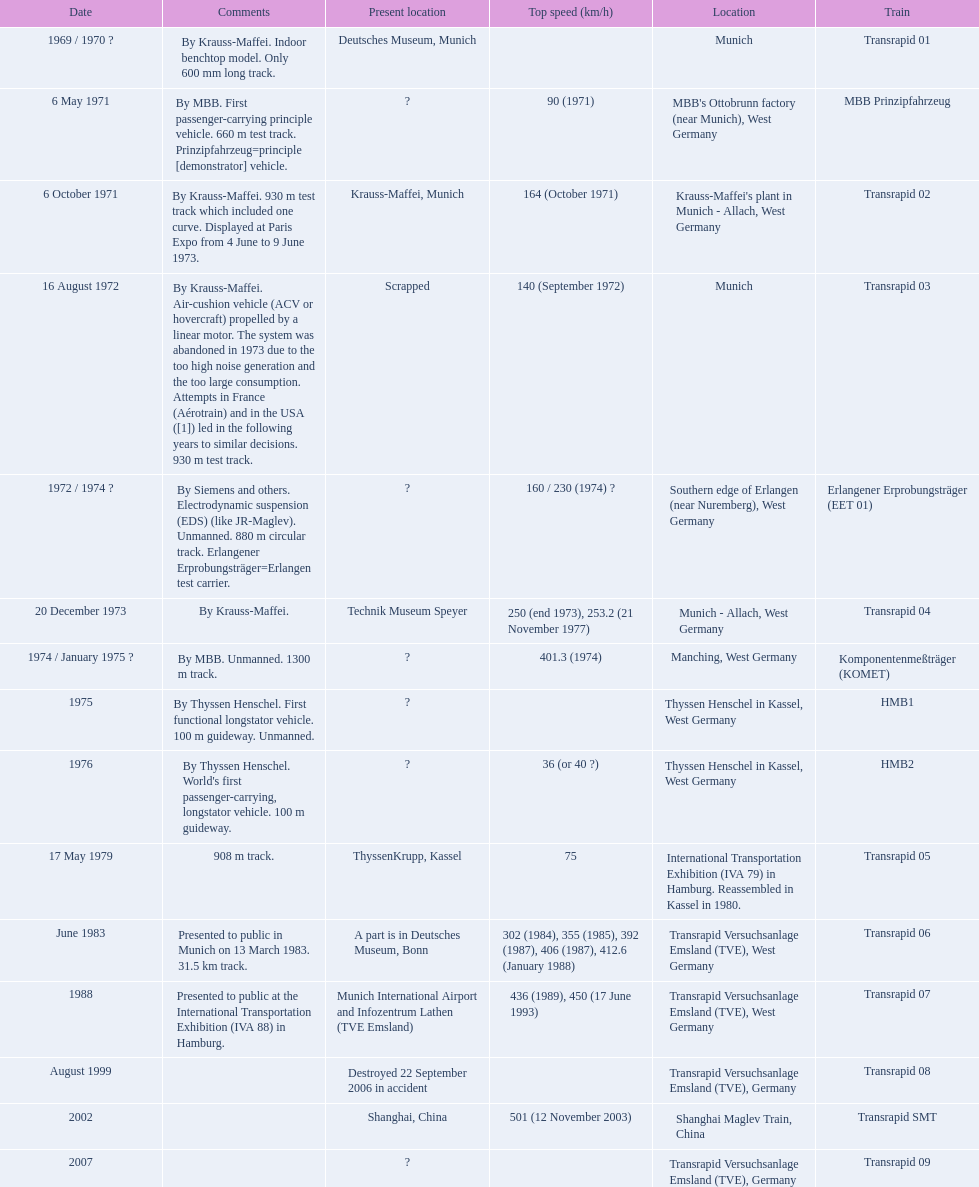Parse the full table. {'header': ['Date', 'Comments', 'Present location', 'Top speed (km/h)', 'Location', 'Train'], 'rows': [['1969 / 1970\xa0?', 'By Krauss-Maffei. Indoor benchtop model. Only 600\xa0mm long track.', 'Deutsches Museum, Munich', '', 'Munich', 'Transrapid 01'], ['6 May 1971', 'By MBB. First passenger-carrying principle vehicle. 660 m test track. Prinzipfahrzeug=principle [demonstrator] vehicle.', '?', '90 (1971)', "MBB's Ottobrunn factory (near Munich), West Germany", 'MBB Prinzipfahrzeug'], ['6 October 1971', 'By Krauss-Maffei. 930 m test track which included one curve. Displayed at Paris Expo from 4 June to 9 June 1973.', 'Krauss-Maffei, Munich', '164 (October 1971)', "Krauss-Maffei's plant in Munich - Allach, West Germany", 'Transrapid 02'], ['16 August 1972', 'By Krauss-Maffei. Air-cushion vehicle (ACV or hovercraft) propelled by a linear motor. The system was abandoned in 1973 due to the too high noise generation and the too large consumption. Attempts in France (Aérotrain) and in the USA ([1]) led in the following years to similar decisions. 930 m test track.', 'Scrapped', '140 (September 1972)', 'Munich', 'Transrapid 03'], ['1972 / 1974\xa0?', 'By Siemens and others. Electrodynamic suspension (EDS) (like JR-Maglev). Unmanned. 880 m circular track. Erlangener Erprobungsträger=Erlangen test carrier.', '?', '160 / 230 (1974)\xa0?', 'Southern edge of Erlangen (near Nuremberg), West Germany', 'Erlangener Erprobungsträger (EET 01)'], ['20 December 1973', 'By Krauss-Maffei.', 'Technik Museum Speyer', '250 (end 1973), 253.2 (21 November 1977)', 'Munich - Allach, West Germany', 'Transrapid 04'], ['1974 / January 1975\xa0?', 'By MBB. Unmanned. 1300 m track.', '?', '401.3 (1974)', 'Manching, West Germany', 'Komponentenmeßträger (KOMET)'], ['1975', 'By Thyssen Henschel. First functional longstator vehicle. 100 m guideway. Unmanned.', '?', '', 'Thyssen Henschel in Kassel, West Germany', 'HMB1'], ['1976', "By Thyssen Henschel. World's first passenger-carrying, longstator vehicle. 100 m guideway.", '?', '36 (or 40\xa0?)', 'Thyssen Henschel in Kassel, West Germany', 'HMB2'], ['17 May 1979', '908 m track.', 'ThyssenKrupp, Kassel', '75', 'International Transportation Exhibition (IVA 79) in Hamburg. Reassembled in Kassel in 1980.', 'Transrapid 05'], ['June 1983', 'Presented to public in Munich on 13 March 1983. 31.5\xa0km track.', 'A part is in Deutsches Museum, Bonn', '302 (1984), 355 (1985), 392 (1987), 406 (1987), 412.6 (January 1988)', 'Transrapid Versuchsanlage Emsland (TVE), West Germany', 'Transrapid 06'], ['1988', 'Presented to public at the International Transportation Exhibition (IVA 88) in Hamburg.', 'Munich International Airport and Infozentrum Lathen (TVE Emsland)', '436 (1989), 450 (17 June 1993)', 'Transrapid Versuchsanlage Emsland (TVE), West Germany', 'Transrapid 07'], ['August 1999', '', 'Destroyed 22 September 2006 in accident', '', 'Transrapid Versuchsanlage Emsland (TVE), Germany', 'Transrapid 08'], ['2002', '', 'Shanghai, China', '501 (12 November 2003)', 'Shanghai Maglev Train, China', 'Transrapid SMT'], ['2007', '', '?', '', 'Transrapid Versuchsanlage Emsland (TVE), Germany', 'Transrapid 09']]} What are the names of each transrapid train? Transrapid 01, MBB Prinzipfahrzeug, Transrapid 02, Transrapid 03, Erlangener Erprobungsträger (EET 01), Transrapid 04, Komponentenmeßträger (KOMET), HMB1, HMB2, Transrapid 05, Transrapid 06, Transrapid 07, Transrapid 08, Transrapid SMT, Transrapid 09. What are their listed top speeds? 90 (1971), 164 (October 1971), 140 (September 1972), 160 / 230 (1974) ?, 250 (end 1973), 253.2 (21 November 1977), 401.3 (1974), 36 (or 40 ?), 75, 302 (1984), 355 (1985), 392 (1987), 406 (1987), 412.6 (January 1988), 436 (1989), 450 (17 June 1993), 501 (12 November 2003). And which train operates at the fastest speed? Transrapid SMT. 